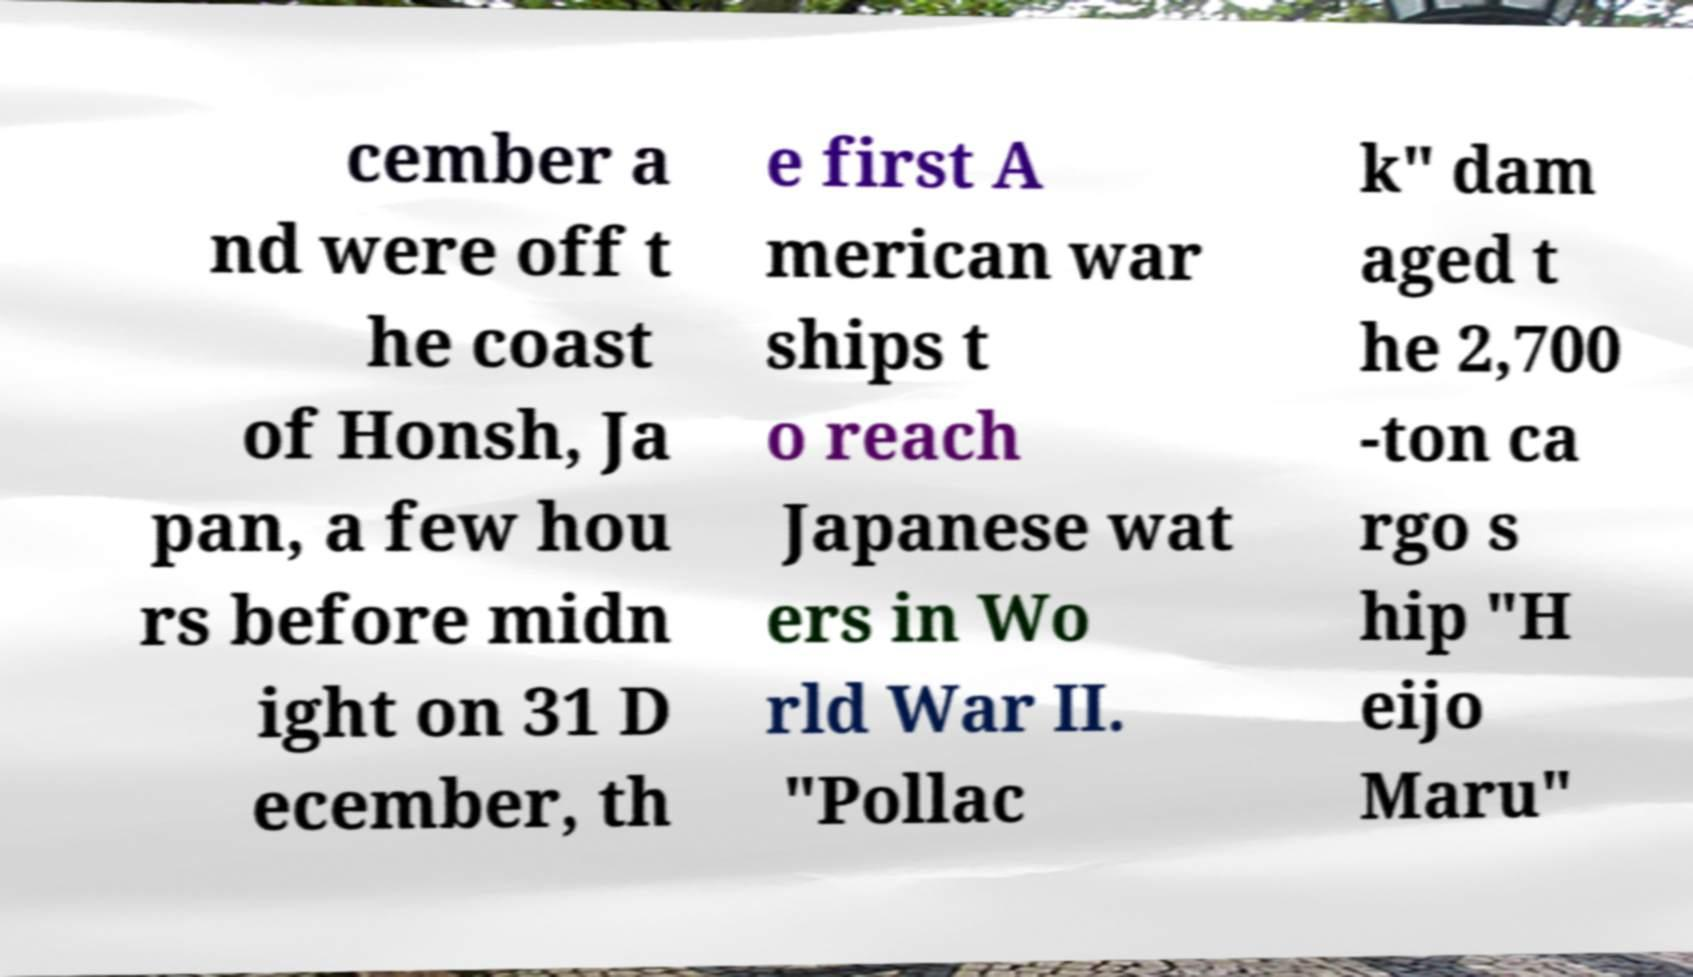Can you read and provide the text displayed in the image?This photo seems to have some interesting text. Can you extract and type it out for me? cember a nd were off t he coast of Honsh, Ja pan, a few hou rs before midn ight on 31 D ecember, th e first A merican war ships t o reach Japanese wat ers in Wo rld War II. "Pollac k" dam aged t he 2,700 -ton ca rgo s hip "H eijo Maru" 